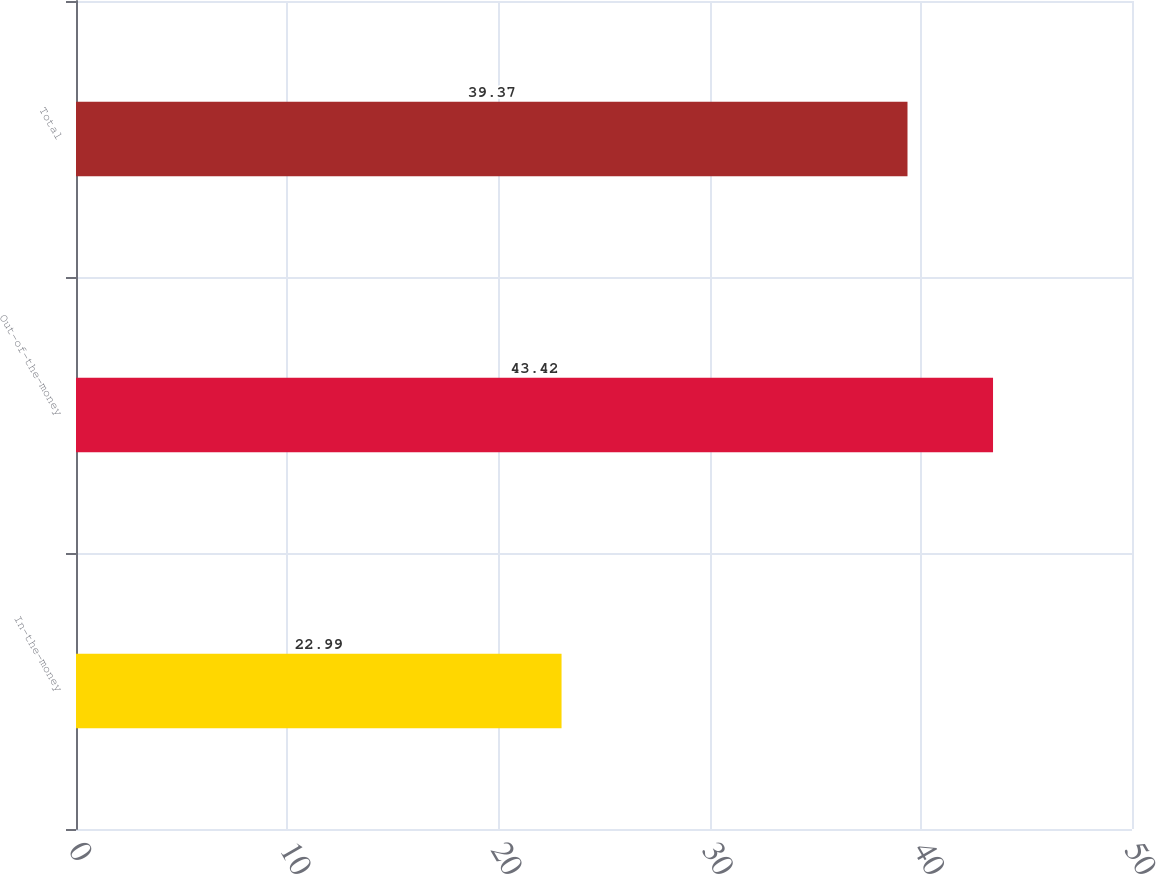Convert chart. <chart><loc_0><loc_0><loc_500><loc_500><bar_chart><fcel>In-the-money<fcel>Out-of-the-money<fcel>Total<nl><fcel>22.99<fcel>43.42<fcel>39.37<nl></chart> 